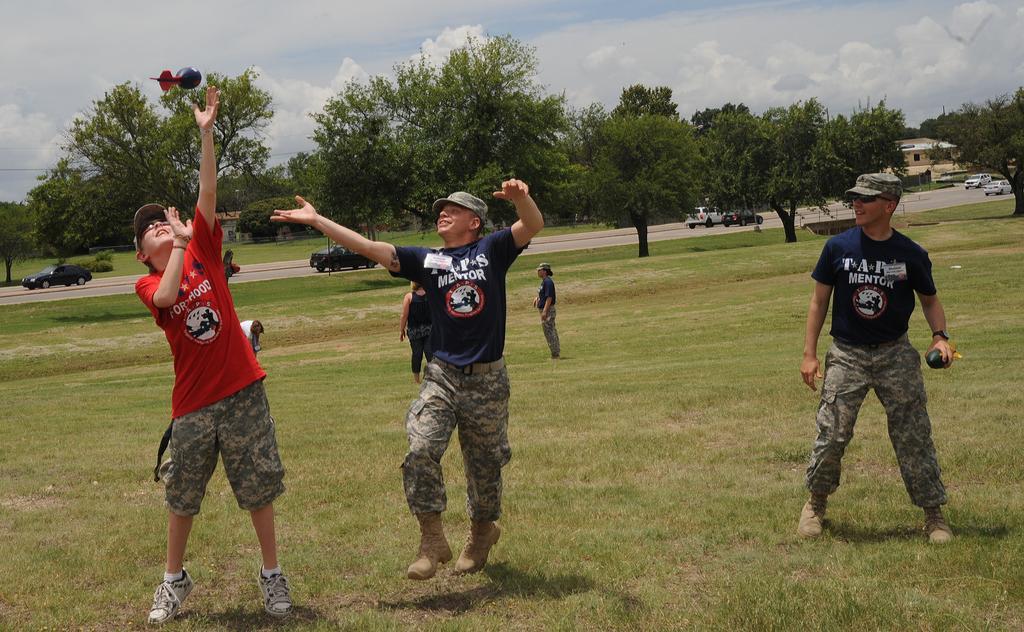Could you give a brief overview of what you see in this image? In this image I can see few people standing and wearing different dress. Back Side I can see few vehicles on the road. I can see a building and trees. The sky is in blue and white color. 